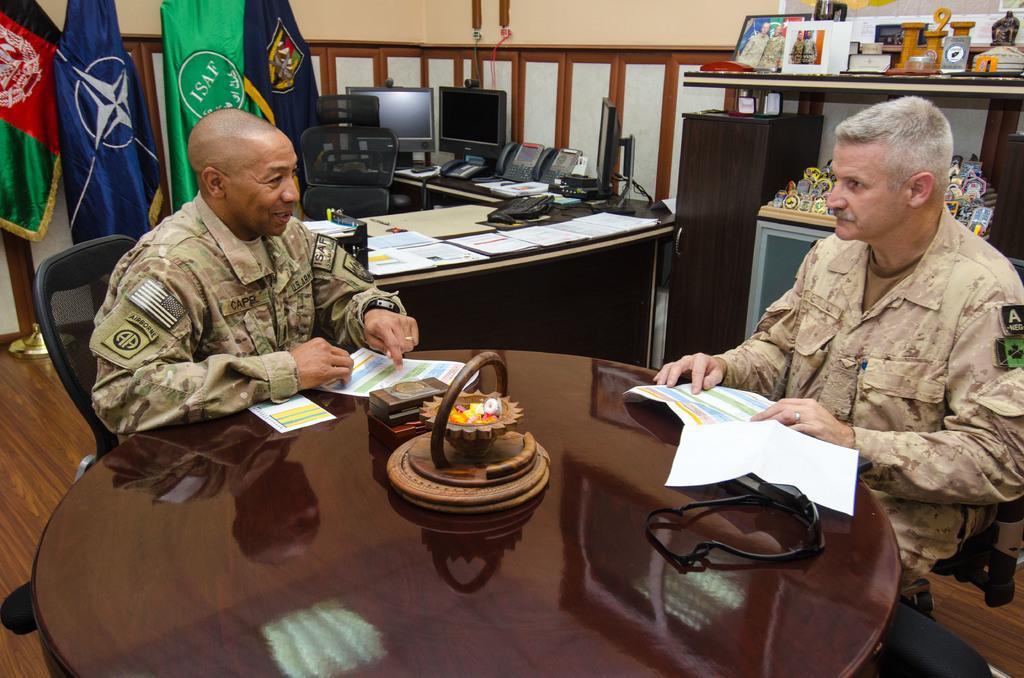How would you summarize this image in a sentence or two? In this image there are two army personnel seated on chairs speaking with each other, in front of them there is a table, on the table there are few papers, behind them there is a table and a chair, on the table there are landline telephones and two monitor, beside the monitor screens there are few flags. 